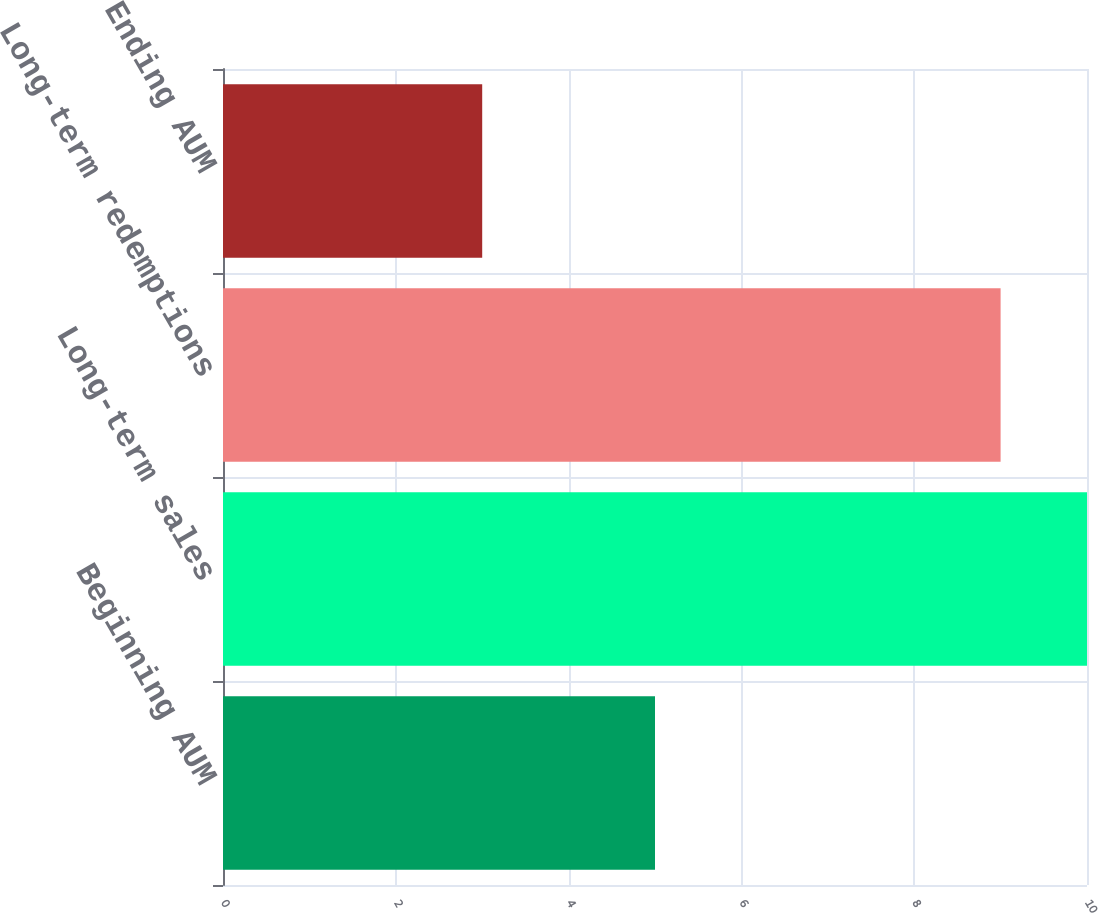Convert chart to OTSL. <chart><loc_0><loc_0><loc_500><loc_500><bar_chart><fcel>Beginning AUM<fcel>Long-term sales<fcel>Long-term redemptions<fcel>Ending AUM<nl><fcel>5<fcel>10<fcel>9<fcel>3<nl></chart> 